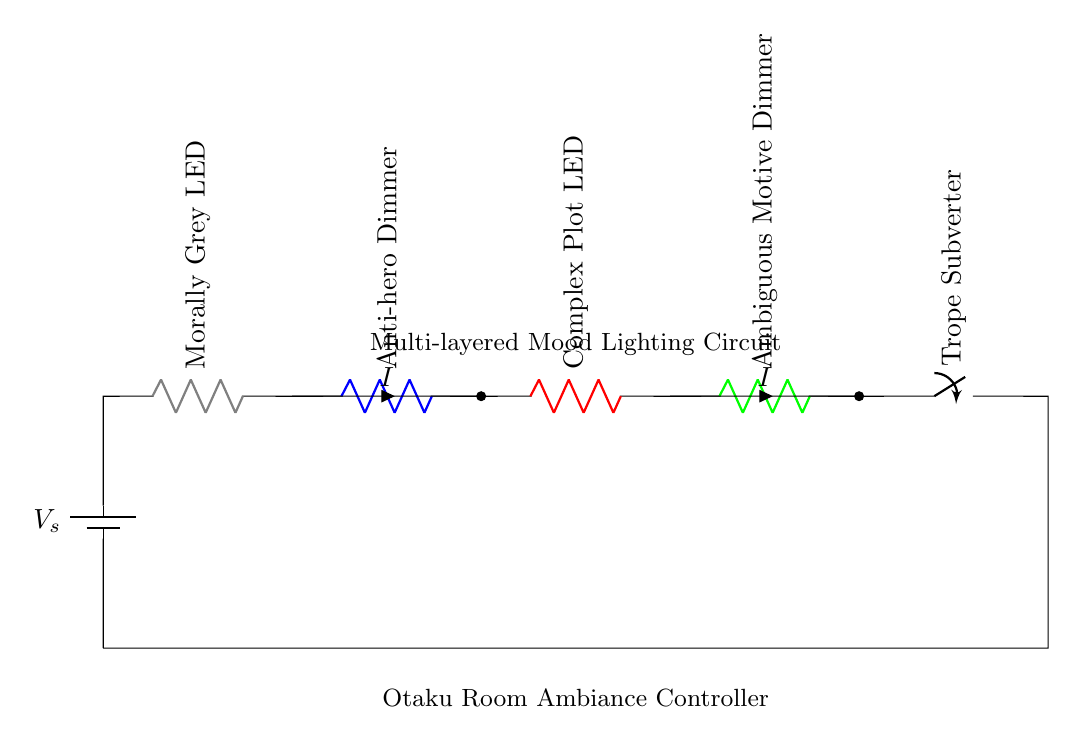What is the primary voltage source in this circuit? The circuit contains a single voltage source labeled as "V_s," providing the necessary electrical potential for the circuit.
Answer: V_s What does the "Trope Subverter" switch control? The "Trope Subverter" switch is positioned at the end of the series circuit, indicating it can control the overall current flow and operation of the connected components, contributing to the thematic nature of the circuit.
Answer: Current flow How many resistors are present in the circuit? By counting the labeled resistors in the circuit, there are four distinct components identified as LEDs or dimmers, indicating their roles in regulating the mood lighting, thus there are four resistors.
Answer: Four Which component is responsible for dimming the effect of the lighting? The dimmers labeled as "Anti-hero Dimmer" and "Ambiguous Motive Dimmer" are specifically designed to adjust and control the brightness of the respective LED lights, making them responsible for dimming the lighting effect.
Answer: Anti-hero Dimmer, Ambiguous Motive Dimmer What color represents the "Morally Grey LED"? In the circuit, the resistor labeled "Morally Grey LED" is depicted in gray, which visually indicates its unique characteristic related to the concept of moral ambiguity.
Answer: Gray Explain the role of the "Complex Plot LED" in the circuit. The "Complex Plot LED," found in series with the other components, symbolizes a source of intricate lighting, reflecting the theme of complexity by potentially having a rich and variable light output as influenced by its position in the circuit structure.
Answer: Intricate lighting How is the current directed through the circuit? The current, labeled as "I," flows through the series path starting from the battery, passing through each resistor in sequence before returning to the source, thus illustrating a continuous direct path for current flow.
Answer: Series path 